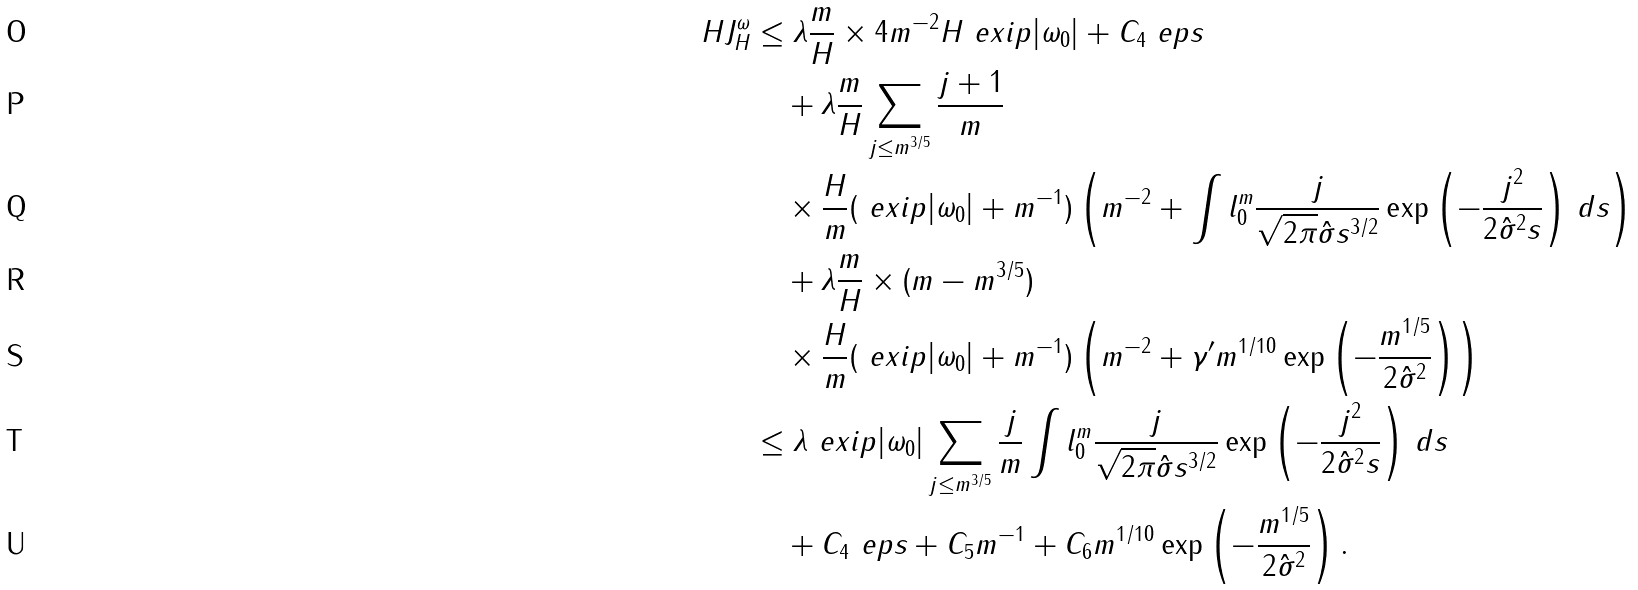<formula> <loc_0><loc_0><loc_500><loc_500>H J ^ { \omega } _ { H } & \leq \lambda \frac { m } { H } \times 4 m ^ { - 2 } H \ e x i p { | \omega _ { 0 } | } + C _ { 4 } \ e p s \\ & \quad + \lambda \frac { m } { H } \sum _ { j \leq m ^ { 3 / 5 } } \frac { j + 1 } { m } \\ & \quad \times \frac { H } { m } ( \ e x i p { | \omega _ { 0 } | } + m ^ { - 1 } ) \left ( m ^ { - 2 } + \int l _ { 0 } ^ { m } \frac { j } { \sqrt { 2 \pi } { \hat { \sigma } } s ^ { 3 / 2 } } \exp \left ( - \frac { j ^ { 2 } } { 2 { \hat { \sigma } } ^ { 2 } s } \right ) \, d s \right ) \\ & \quad + \lambda \frac { m } { H } \times ( m - m ^ { 3 / 5 } ) \\ & \quad \times \frac { H } { m } ( \ e x i p { | \omega _ { 0 } | } + m ^ { - 1 } ) \left ( m ^ { - 2 } + \gamma ^ { \prime } m ^ { 1 / 1 0 } \exp \left ( - \frac { m ^ { 1 / 5 } } { 2 { \hat { \sigma } } ^ { 2 } } \right ) \right ) \\ & \leq \lambda \ e x i p { | \omega _ { 0 } | } \sum _ { j \leq m ^ { 3 / 5 } } \frac { j } { m } \int l _ { 0 } ^ { m } \frac { j } { \sqrt { 2 \pi } { \hat { \sigma } } s ^ { 3 / 2 } } \exp \left ( - \frac { j ^ { 2 } } { 2 { \hat { \sigma } } ^ { 2 } s } \right ) \, d s \\ & \quad + C _ { 4 } \ e p s + C _ { 5 } m ^ { - 1 } + C _ { 6 } m ^ { 1 / 1 0 } \exp \left ( - \frac { m ^ { 1 / 5 } } { 2 { \hat { \sigma } } ^ { 2 } } \right ) .</formula> 